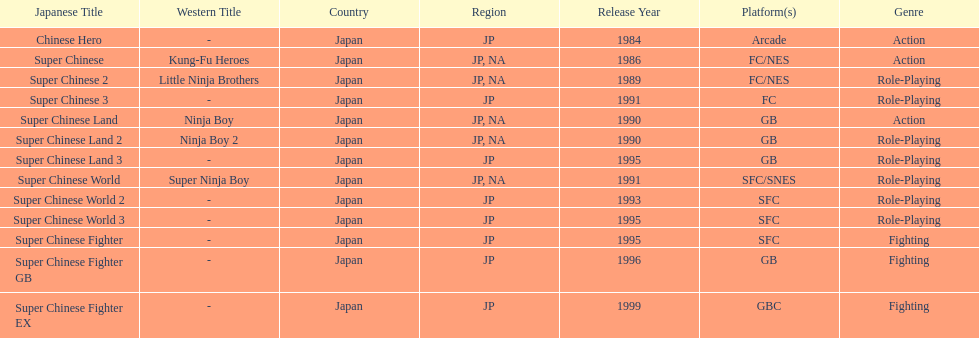Number of super chinese world games released 3. Could you parse the entire table as a dict? {'header': ['Japanese Title', 'Western Title', 'Country', 'Region', 'Release Year', 'Platform(s)', 'Genre'], 'rows': [['Chinese Hero', '-', 'Japan', 'JP', '1984', 'Arcade', 'Action'], ['Super Chinese', 'Kung-Fu Heroes', 'Japan', 'JP, NA', '1986', 'FC/NES', 'Action'], ['Super Chinese 2', 'Little Ninja Brothers', 'Japan', 'JP, NA', '1989', 'FC/NES', 'Role-Playing'], ['Super Chinese 3', '-', 'Japan', 'JP', '1991', 'FC', 'Role-Playing'], ['Super Chinese Land', 'Ninja Boy', 'Japan', 'JP, NA', '1990', 'GB', 'Action'], ['Super Chinese Land 2', 'Ninja Boy 2', 'Japan', 'JP, NA', '1990', 'GB', 'Role-Playing'], ['Super Chinese Land 3', '-', 'Japan', 'JP', '1995', 'GB', 'Role-Playing'], ['Super Chinese World', 'Super Ninja Boy', 'Japan', 'JP, NA', '1991', 'SFC/SNES', 'Role-Playing'], ['Super Chinese World 2', '-', 'Japan', 'JP', '1993', 'SFC', 'Role-Playing'], ['Super Chinese World 3', '-', 'Japan', 'JP', '1995', 'SFC', 'Role-Playing'], ['Super Chinese Fighter', '-', 'Japan', 'JP', '1995', 'SFC', 'Fighting'], ['Super Chinese Fighter GB', '-', 'Japan', 'JP', '1996', 'GB', 'Fighting'], ['Super Chinese Fighter EX', '-', 'Japan', 'JP', '1999', 'GBC', 'Fighting']]} 